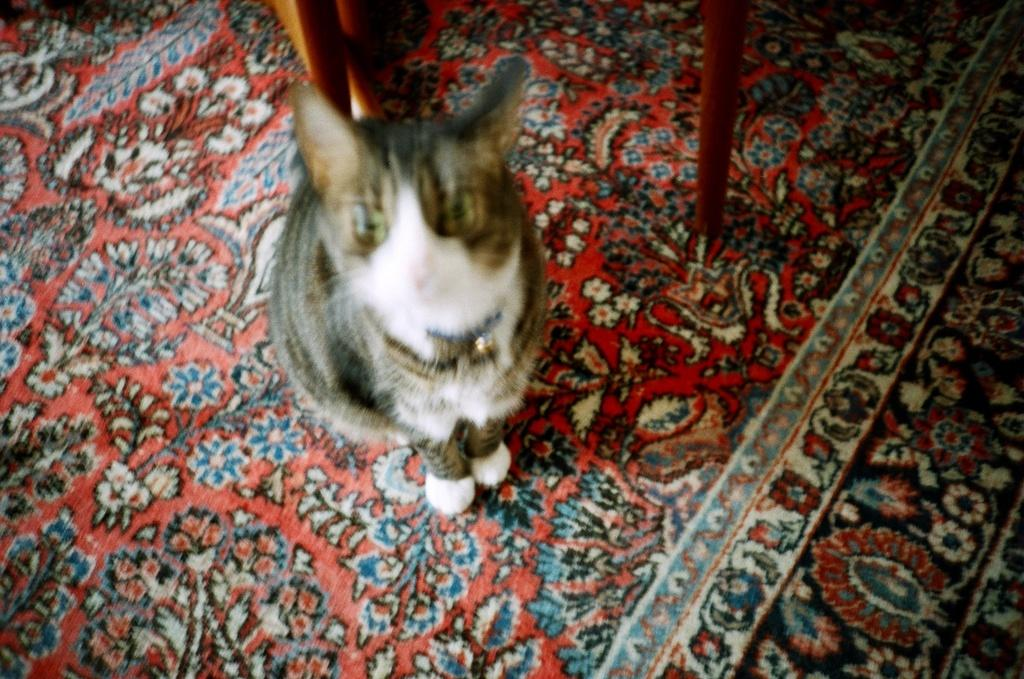What type of animal is in the image? There is a cat in the image. What colors can be seen on the cat? The cat has white, black, and grey colors. What is the cat standing on? The cat is standing on a floor mat. What type of objects can be seen with a brown color in the image? There are brown-colored wooden objects in the image. What type of gold object is being used to light a match in the image? There is no gold object or match present in the image. How is the hose connected to the water source in the image? There is no hose present in the image. 